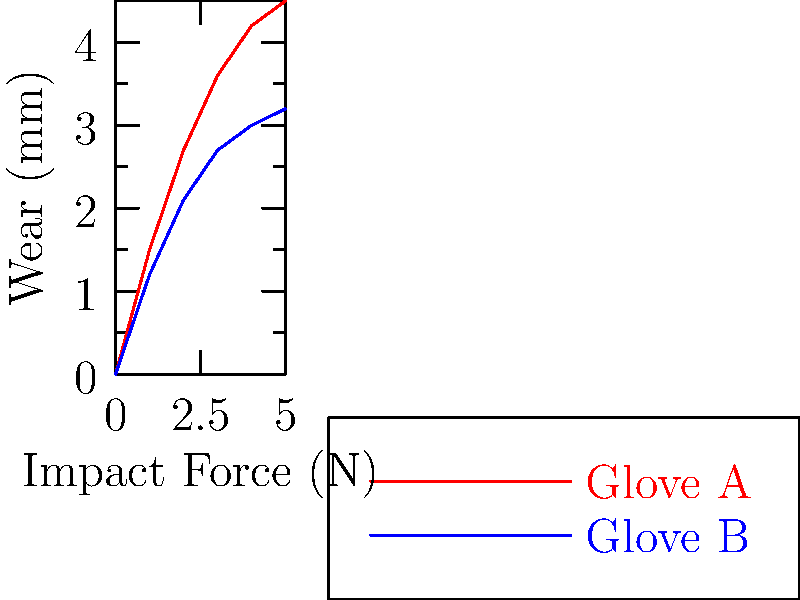Based on the impact force graphs for two goalkeeper gloves, which glove is likely to have better durability during intense training sessions? To determine which glove has better durability, we need to analyze the relationship between impact force and wear for both gloves:

1. Observe the graph:
   - Red line represents Glove A
   - Blue line represents Glove B

2. Compare the slopes:
   - Glove A (red) has a steeper slope
   - Glove B (blue) has a gentler slope

3. Interpret the slopes:
   - A steeper slope indicates more wear per unit of impact force
   - A gentler slope indicates less wear per unit of impact force

4. Analyze durability:
   - Glove B shows less wear at higher impact forces
   - This suggests Glove B is more resistant to wear during intense impacts

5. Consider training implications:
   - Intense training sessions involve repeated high-impact saves
   - Glove B would likely withstand these impacts better over time

Therefore, Glove B is likely to have better durability during intense training sessions due to its lower wear rate at higher impact forces.
Answer: Glove B 